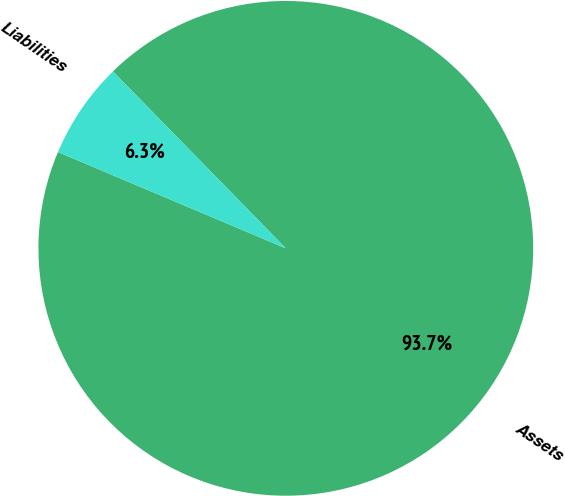<chart> <loc_0><loc_0><loc_500><loc_500><pie_chart><fcel>Assets<fcel>Liabilities<nl><fcel>93.68%<fcel>6.32%<nl></chart> 